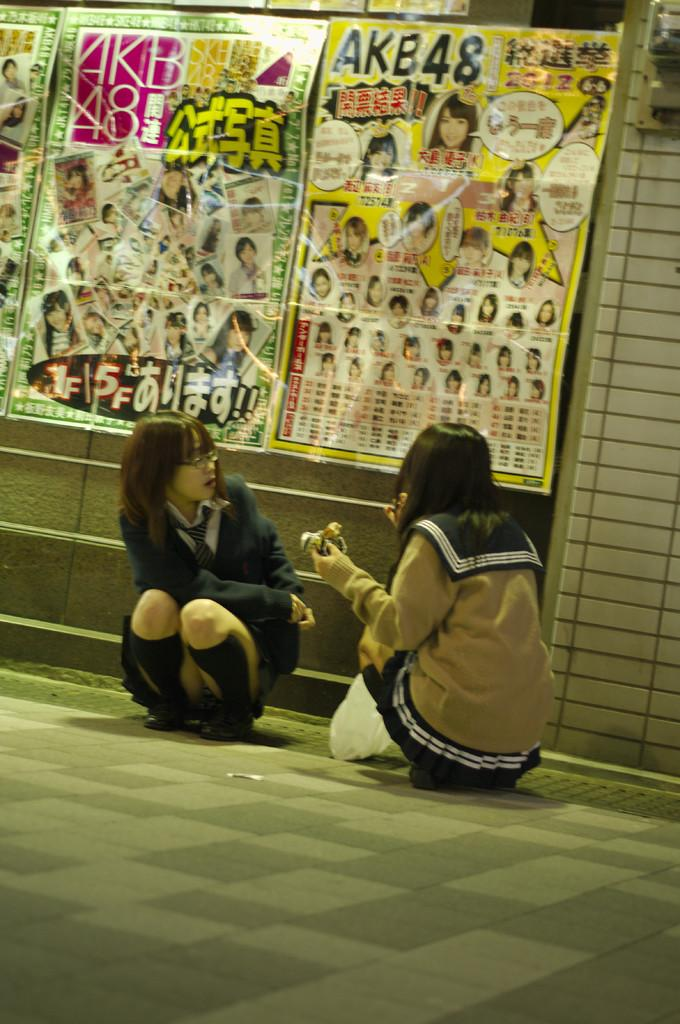How many people are sitting in the image? There are two girls sitting in the image. What are the girls wearing in the image? The girls are wearing coats in the image. What can be seen on the wall in the image? There are papers stuck to the wall in the image. What type of quicksand can be seen in the image? There is no quicksand present in the image. What scene is being depicted in the image? The image does not depict a specific scene; it simply shows two girls sitting and papers stuck to the wall. 